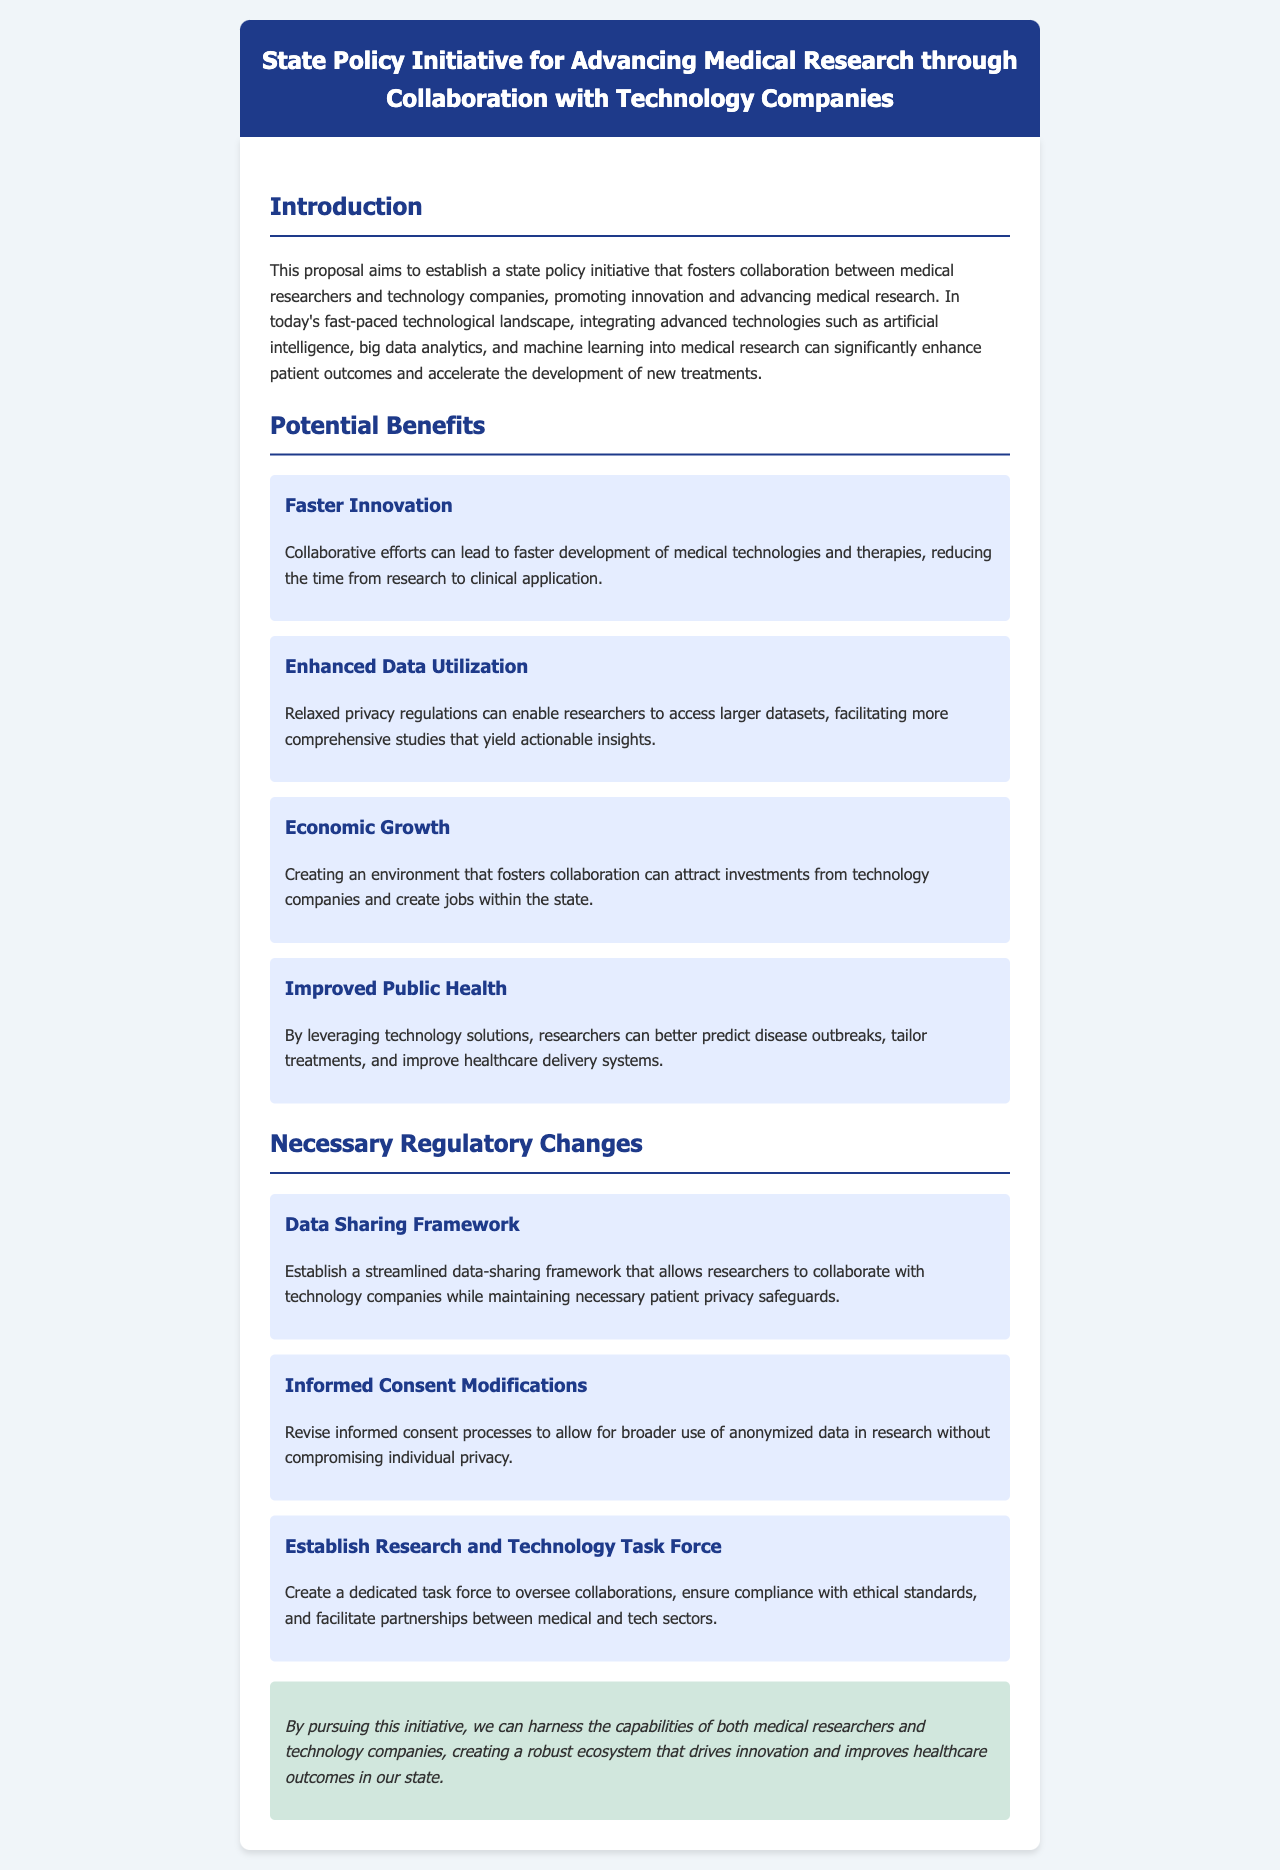What is the title of the initiative? The title of the initiative is mentioned in the header section of the document.
Answer: State Policy Initiative for Advancing Medical Research through Collaboration with Technology Companies What is one potential benefit of collaboration? One potential benefit is highlighted in the section discussing the advantages of collaboration.
Answer: Faster Innovation How many necessary regulatory changes are outlined in the document? The number of regulatory changes is specified in the section regarding necessary changes.
Answer: Three Which technology is mentioned as part of the advanced technologies integration? The document lists several technologies; one of them is highlighted prominently.
Answer: Artificial intelligence What is proposed to better oversee collaborations? The proposal includes the establishment of a specific entity to manage partnerships.
Answer: Research and Technology Task Force What kind of data access is suggested to enhance research? The document refers to a specific modification regarding data access to facilitate better research outcomes.
Answer: Larger datasets What overall impact does the initiative aim to create? The conclusion of the document summarizes the broader goal of the initiative.
Answer: Robust ecosystem What type of document is this? The format and content suggest it is aimed at proposing a change in policy.
Answer: Proposal 